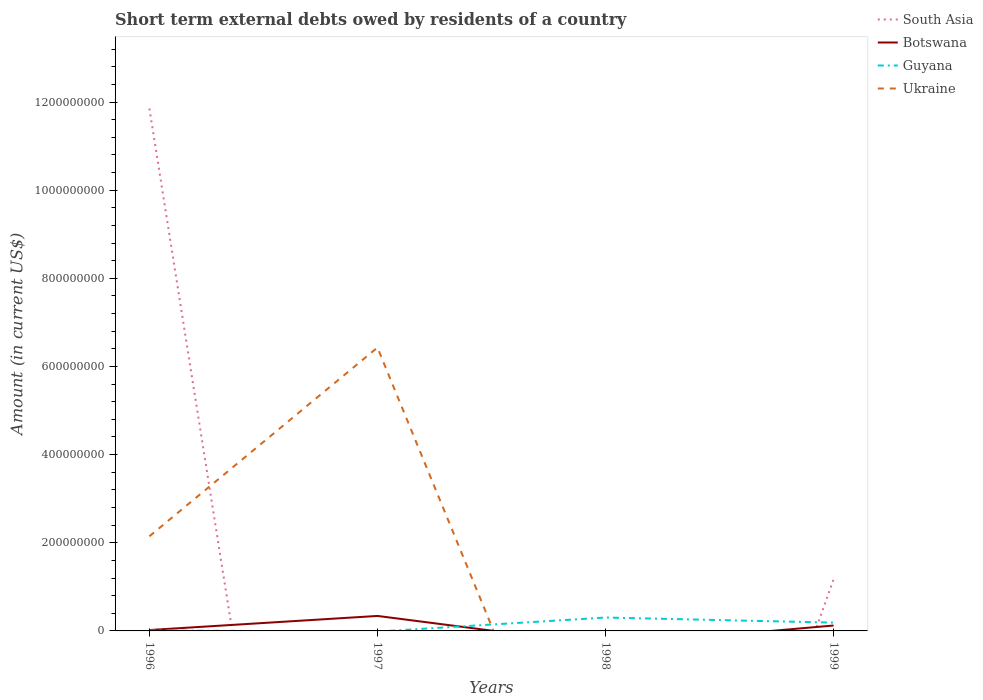Does the line corresponding to Botswana intersect with the line corresponding to Guyana?
Provide a short and direct response. Yes. What is the total amount of short-term external debts owed by residents in Guyana in the graph?
Ensure brevity in your answer.  -2.94e+07. What is the difference between the highest and the second highest amount of short-term external debts owed by residents in Botswana?
Your response must be concise. 3.40e+07. How many lines are there?
Provide a succinct answer. 4. Are the values on the major ticks of Y-axis written in scientific E-notation?
Your answer should be compact. No. Does the graph contain grids?
Make the answer very short. No. Where does the legend appear in the graph?
Provide a short and direct response. Top right. How are the legend labels stacked?
Provide a succinct answer. Vertical. What is the title of the graph?
Your answer should be compact. Short term external debts owed by residents of a country. Does "Central Europe" appear as one of the legend labels in the graph?
Provide a succinct answer. No. What is the label or title of the X-axis?
Ensure brevity in your answer.  Years. What is the Amount (in current US$) in South Asia in 1996?
Your response must be concise. 1.19e+09. What is the Amount (in current US$) of Botswana in 1996?
Provide a succinct answer. 2.02e+06. What is the Amount (in current US$) of Guyana in 1996?
Your answer should be very brief. 1.01e+06. What is the Amount (in current US$) in Ukraine in 1996?
Ensure brevity in your answer.  2.15e+08. What is the Amount (in current US$) of Botswana in 1997?
Provide a short and direct response. 3.40e+07. What is the Amount (in current US$) in Guyana in 1997?
Give a very brief answer. 0. What is the Amount (in current US$) of Ukraine in 1997?
Ensure brevity in your answer.  6.43e+08. What is the Amount (in current US$) of South Asia in 1998?
Provide a short and direct response. 0. What is the Amount (in current US$) in Botswana in 1998?
Provide a succinct answer. 0. What is the Amount (in current US$) in Guyana in 1998?
Your answer should be very brief. 3.04e+07. What is the Amount (in current US$) in South Asia in 1999?
Offer a very short reply. 1.17e+08. What is the Amount (in current US$) of Botswana in 1999?
Provide a short and direct response. 1.23e+07. What is the Amount (in current US$) in Guyana in 1999?
Keep it short and to the point. 1.89e+07. What is the Amount (in current US$) in Ukraine in 1999?
Ensure brevity in your answer.  0. Across all years, what is the maximum Amount (in current US$) in South Asia?
Make the answer very short. 1.19e+09. Across all years, what is the maximum Amount (in current US$) of Botswana?
Your response must be concise. 3.40e+07. Across all years, what is the maximum Amount (in current US$) of Guyana?
Offer a very short reply. 3.04e+07. Across all years, what is the maximum Amount (in current US$) of Ukraine?
Offer a very short reply. 6.43e+08. Across all years, what is the minimum Amount (in current US$) of South Asia?
Make the answer very short. 0. Across all years, what is the minimum Amount (in current US$) in Guyana?
Keep it short and to the point. 0. Across all years, what is the minimum Amount (in current US$) of Ukraine?
Offer a very short reply. 0. What is the total Amount (in current US$) in South Asia in the graph?
Your answer should be very brief. 1.30e+09. What is the total Amount (in current US$) in Botswana in the graph?
Give a very brief answer. 4.83e+07. What is the total Amount (in current US$) of Guyana in the graph?
Make the answer very short. 5.02e+07. What is the total Amount (in current US$) in Ukraine in the graph?
Make the answer very short. 8.58e+08. What is the difference between the Amount (in current US$) of Botswana in 1996 and that in 1997?
Offer a terse response. -3.20e+07. What is the difference between the Amount (in current US$) of Ukraine in 1996 and that in 1997?
Give a very brief answer. -4.28e+08. What is the difference between the Amount (in current US$) of Guyana in 1996 and that in 1998?
Give a very brief answer. -2.94e+07. What is the difference between the Amount (in current US$) in South Asia in 1996 and that in 1999?
Provide a succinct answer. 1.07e+09. What is the difference between the Amount (in current US$) of Botswana in 1996 and that in 1999?
Make the answer very short. -1.03e+07. What is the difference between the Amount (in current US$) of Guyana in 1996 and that in 1999?
Your answer should be compact. -1.79e+07. What is the difference between the Amount (in current US$) of Botswana in 1997 and that in 1999?
Give a very brief answer. 2.17e+07. What is the difference between the Amount (in current US$) of Guyana in 1998 and that in 1999?
Your response must be concise. 1.15e+07. What is the difference between the Amount (in current US$) in South Asia in 1996 and the Amount (in current US$) in Botswana in 1997?
Provide a succinct answer. 1.15e+09. What is the difference between the Amount (in current US$) of South Asia in 1996 and the Amount (in current US$) of Ukraine in 1997?
Offer a very short reply. 5.42e+08. What is the difference between the Amount (in current US$) in Botswana in 1996 and the Amount (in current US$) in Ukraine in 1997?
Your response must be concise. -6.41e+08. What is the difference between the Amount (in current US$) of Guyana in 1996 and the Amount (in current US$) of Ukraine in 1997?
Ensure brevity in your answer.  -6.42e+08. What is the difference between the Amount (in current US$) in South Asia in 1996 and the Amount (in current US$) in Guyana in 1998?
Provide a short and direct response. 1.15e+09. What is the difference between the Amount (in current US$) of Botswana in 1996 and the Amount (in current US$) of Guyana in 1998?
Provide a succinct answer. -2.84e+07. What is the difference between the Amount (in current US$) of South Asia in 1996 and the Amount (in current US$) of Botswana in 1999?
Keep it short and to the point. 1.17e+09. What is the difference between the Amount (in current US$) of South Asia in 1996 and the Amount (in current US$) of Guyana in 1999?
Your answer should be very brief. 1.17e+09. What is the difference between the Amount (in current US$) in Botswana in 1996 and the Amount (in current US$) in Guyana in 1999?
Your answer should be compact. -1.68e+07. What is the difference between the Amount (in current US$) in Botswana in 1997 and the Amount (in current US$) in Guyana in 1998?
Keep it short and to the point. 3.63e+06. What is the difference between the Amount (in current US$) of Botswana in 1997 and the Amount (in current US$) of Guyana in 1999?
Keep it short and to the point. 1.51e+07. What is the average Amount (in current US$) in South Asia per year?
Offer a very short reply. 3.26e+08. What is the average Amount (in current US$) of Botswana per year?
Offer a very short reply. 1.21e+07. What is the average Amount (in current US$) in Guyana per year?
Your answer should be very brief. 1.26e+07. What is the average Amount (in current US$) of Ukraine per year?
Provide a succinct answer. 2.14e+08. In the year 1996, what is the difference between the Amount (in current US$) in South Asia and Amount (in current US$) in Botswana?
Keep it short and to the point. 1.18e+09. In the year 1996, what is the difference between the Amount (in current US$) in South Asia and Amount (in current US$) in Guyana?
Provide a succinct answer. 1.18e+09. In the year 1996, what is the difference between the Amount (in current US$) of South Asia and Amount (in current US$) of Ukraine?
Your answer should be very brief. 9.71e+08. In the year 1996, what is the difference between the Amount (in current US$) of Botswana and Amount (in current US$) of Guyana?
Offer a very short reply. 1.01e+06. In the year 1996, what is the difference between the Amount (in current US$) in Botswana and Amount (in current US$) in Ukraine?
Keep it short and to the point. -2.13e+08. In the year 1996, what is the difference between the Amount (in current US$) of Guyana and Amount (in current US$) of Ukraine?
Your answer should be very brief. -2.14e+08. In the year 1997, what is the difference between the Amount (in current US$) in Botswana and Amount (in current US$) in Ukraine?
Your answer should be compact. -6.09e+08. In the year 1999, what is the difference between the Amount (in current US$) of South Asia and Amount (in current US$) of Botswana?
Offer a very short reply. 1.05e+08. In the year 1999, what is the difference between the Amount (in current US$) of South Asia and Amount (in current US$) of Guyana?
Your answer should be compact. 9.83e+07. In the year 1999, what is the difference between the Amount (in current US$) of Botswana and Amount (in current US$) of Guyana?
Your response must be concise. -6.59e+06. What is the ratio of the Amount (in current US$) in Botswana in 1996 to that in 1997?
Make the answer very short. 0.06. What is the ratio of the Amount (in current US$) in Ukraine in 1996 to that in 1997?
Your response must be concise. 0.33. What is the ratio of the Amount (in current US$) in South Asia in 1996 to that in 1999?
Keep it short and to the point. 10.12. What is the ratio of the Amount (in current US$) in Botswana in 1996 to that in 1999?
Make the answer very short. 0.16. What is the ratio of the Amount (in current US$) in Guyana in 1996 to that in 1999?
Offer a very short reply. 0.05. What is the ratio of the Amount (in current US$) in Botswana in 1997 to that in 1999?
Ensure brevity in your answer.  2.77. What is the ratio of the Amount (in current US$) of Guyana in 1998 to that in 1999?
Give a very brief answer. 1.61. What is the difference between the highest and the second highest Amount (in current US$) of Botswana?
Offer a terse response. 2.17e+07. What is the difference between the highest and the second highest Amount (in current US$) of Guyana?
Make the answer very short. 1.15e+07. What is the difference between the highest and the lowest Amount (in current US$) of South Asia?
Your answer should be very brief. 1.19e+09. What is the difference between the highest and the lowest Amount (in current US$) in Botswana?
Make the answer very short. 3.40e+07. What is the difference between the highest and the lowest Amount (in current US$) of Guyana?
Keep it short and to the point. 3.04e+07. What is the difference between the highest and the lowest Amount (in current US$) of Ukraine?
Make the answer very short. 6.43e+08. 